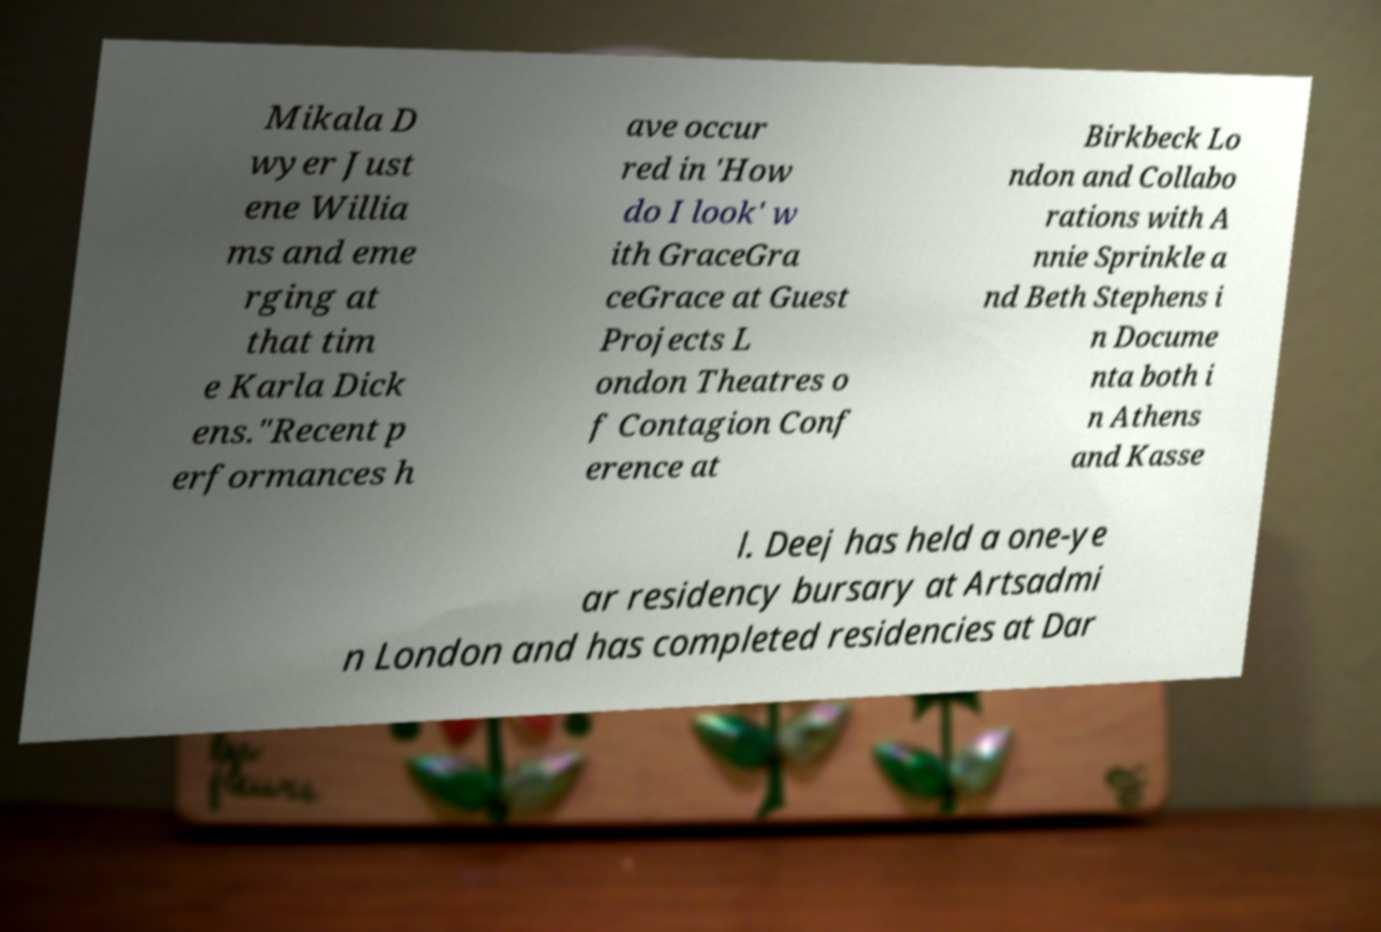Could you assist in decoding the text presented in this image and type it out clearly? Mikala D wyer Just ene Willia ms and eme rging at that tim e Karla Dick ens."Recent p erformances h ave occur red in 'How do I look' w ith GraceGra ceGrace at Guest Projects L ondon Theatres o f Contagion Conf erence at Birkbeck Lo ndon and Collabo rations with A nnie Sprinkle a nd Beth Stephens i n Docume nta both i n Athens and Kasse l. Deej has held a one-ye ar residency bursary at Artsadmi n London and has completed residencies at Dar 